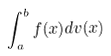<formula> <loc_0><loc_0><loc_500><loc_500>\int _ { a } ^ { b } f ( x ) d v ( x )</formula> 